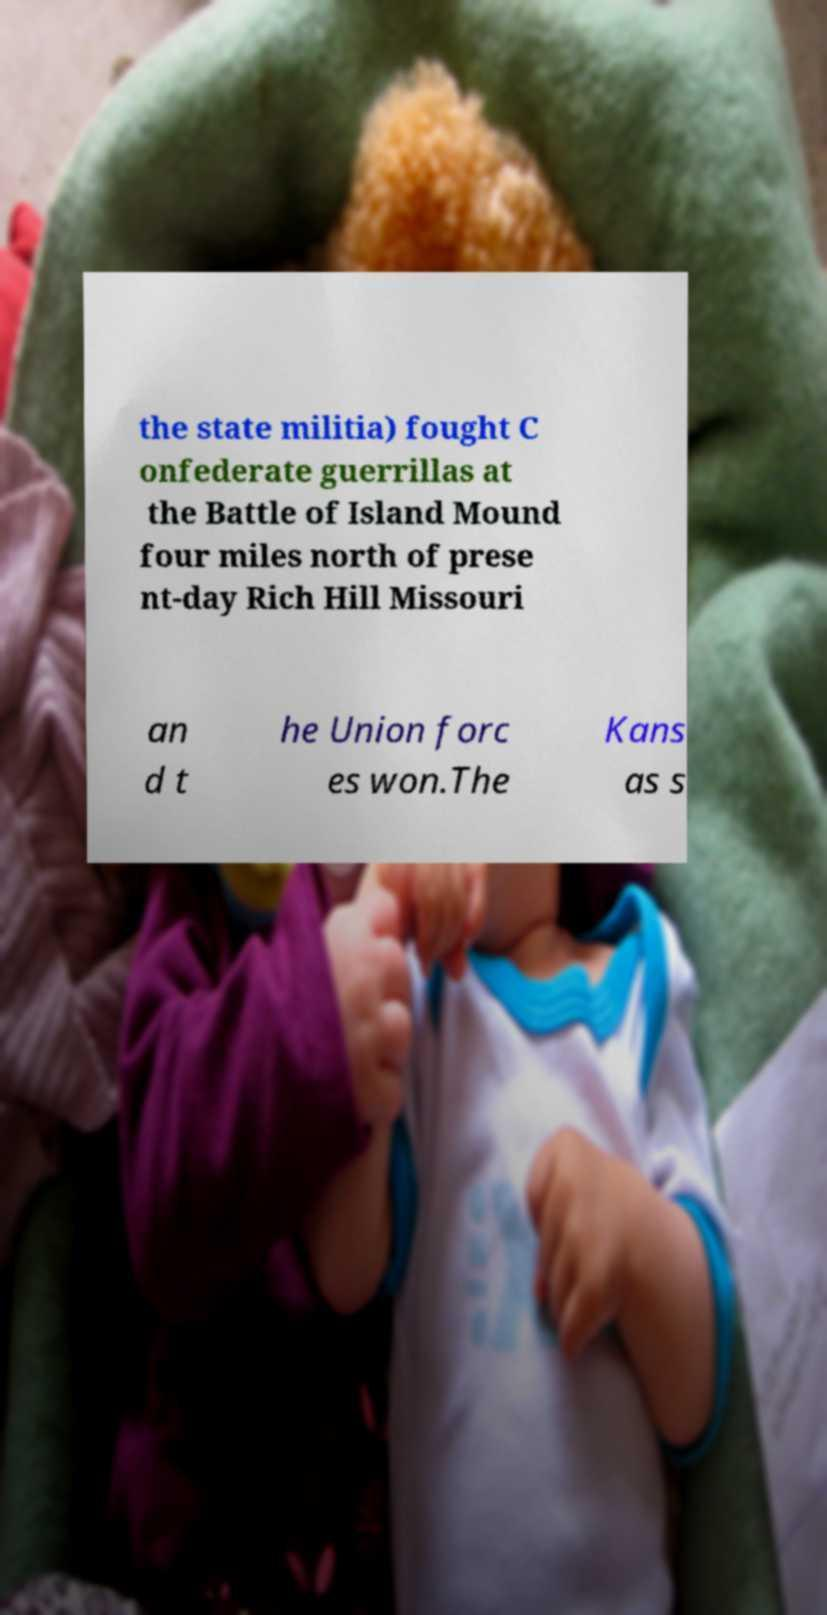Could you assist in decoding the text presented in this image and type it out clearly? the state militia) fought C onfederate guerrillas at the Battle of Island Mound four miles north of prese nt-day Rich Hill Missouri an d t he Union forc es won.The Kans as s 